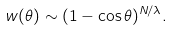Convert formula to latex. <formula><loc_0><loc_0><loc_500><loc_500>w ( \theta ) \sim ( 1 - \cos \theta ) ^ { N / \lambda } .</formula> 